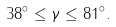Convert formula to latex. <formula><loc_0><loc_0><loc_500><loc_500>3 8 ^ { \circ } \leq \gamma \leq 8 1 ^ { \circ } .</formula> 